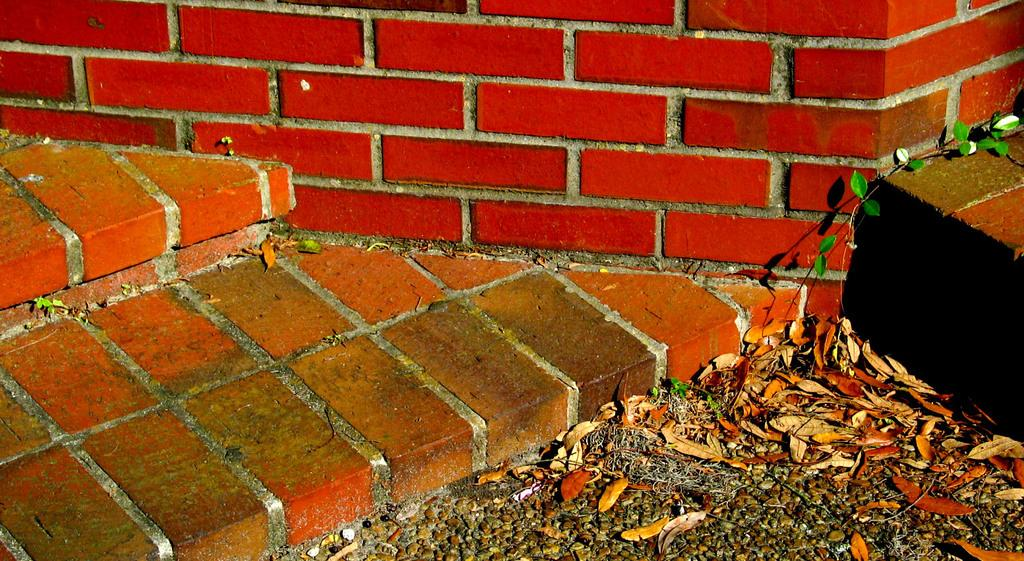What type of surface is visible on the wall and floor in the image? There is a brick wall and a brick floor in the image. What type of vegetation can be seen in the image? There are leaves and a creeper in the image. Where is the sofa located in the image? There is no sofa present in the image. What time does the clock show in the image? There is no clock present in the image. 